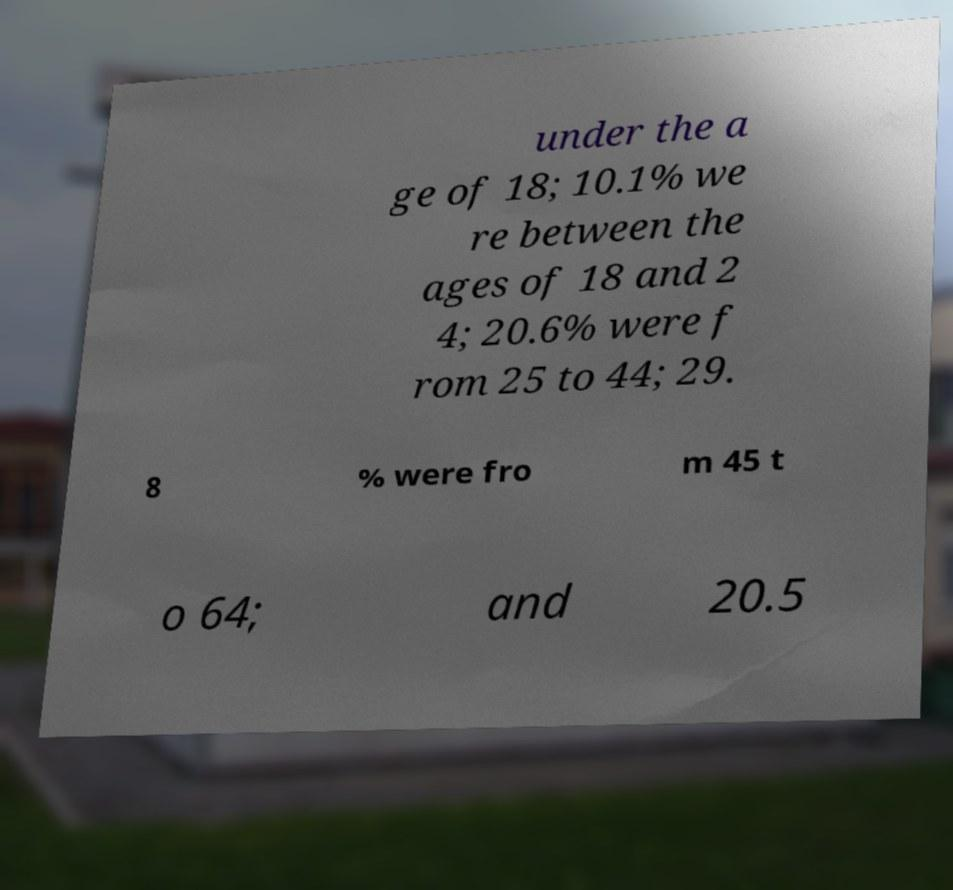What messages or text are displayed in this image? I need them in a readable, typed format. under the a ge of 18; 10.1% we re between the ages of 18 and 2 4; 20.6% were f rom 25 to 44; 29. 8 % were fro m 45 t o 64; and 20.5 